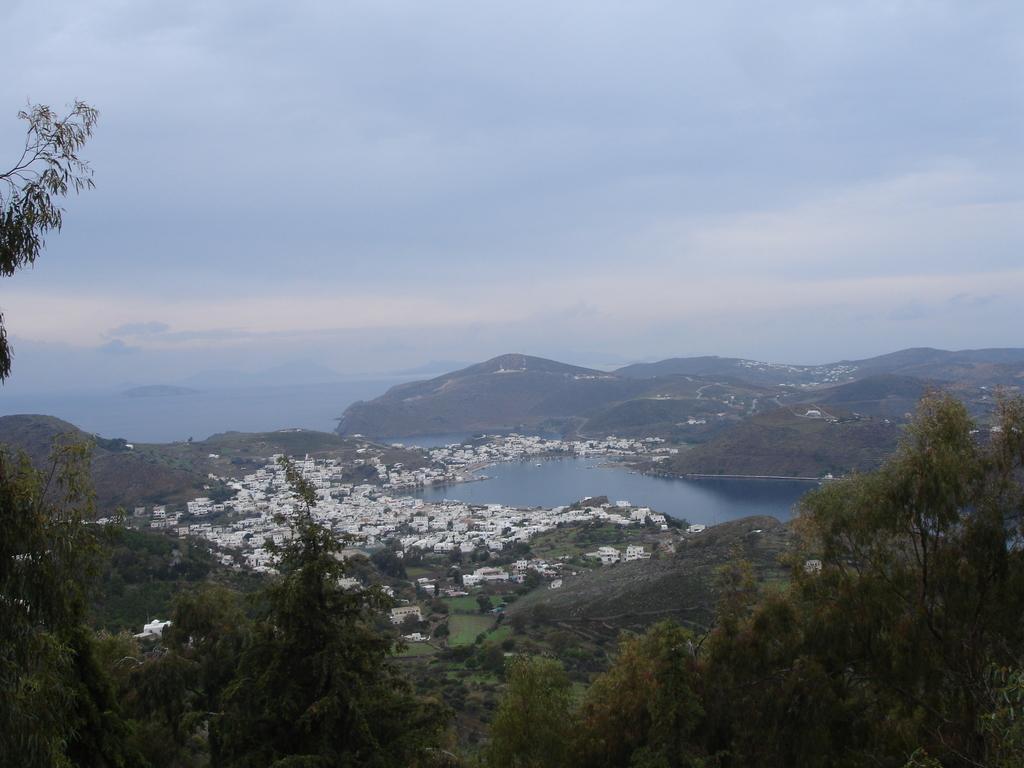In one or two sentences, can you explain what this image depicts? In this image we can see a group of buildings, housing, a group of trees and a large water body. We can also see the hills and the sky which looks cloudy. 